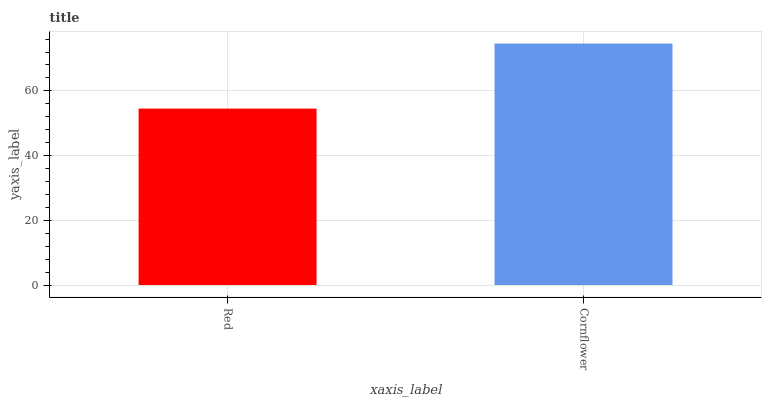Is Red the minimum?
Answer yes or no. Yes. Is Cornflower the maximum?
Answer yes or no. Yes. Is Cornflower the minimum?
Answer yes or no. No. Is Cornflower greater than Red?
Answer yes or no. Yes. Is Red less than Cornflower?
Answer yes or no. Yes. Is Red greater than Cornflower?
Answer yes or no. No. Is Cornflower less than Red?
Answer yes or no. No. Is Cornflower the high median?
Answer yes or no. Yes. Is Red the low median?
Answer yes or no. Yes. Is Red the high median?
Answer yes or no. No. Is Cornflower the low median?
Answer yes or no. No. 